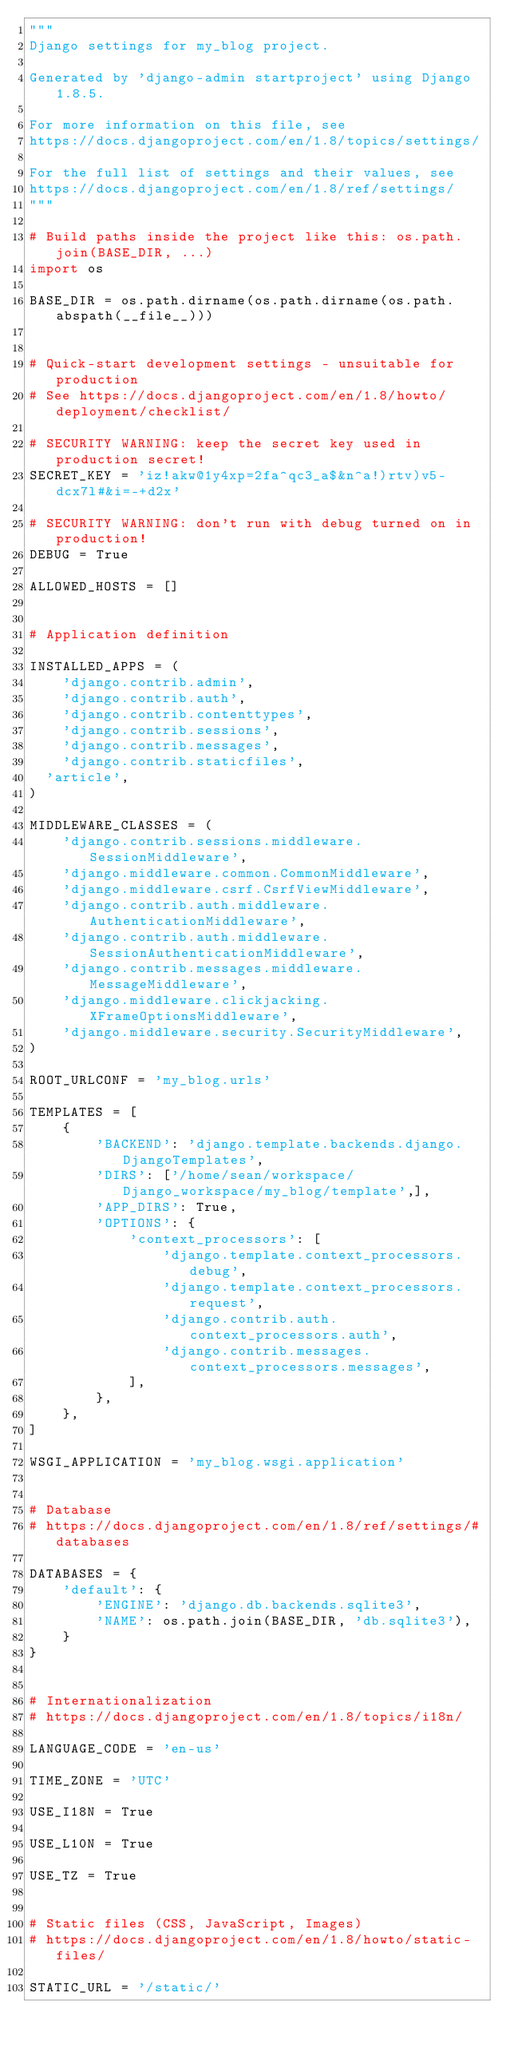Convert code to text. <code><loc_0><loc_0><loc_500><loc_500><_Python_>"""
Django settings for my_blog project.

Generated by 'django-admin startproject' using Django 1.8.5.

For more information on this file, see
https://docs.djangoproject.com/en/1.8/topics/settings/

For the full list of settings and their values, see
https://docs.djangoproject.com/en/1.8/ref/settings/
"""

# Build paths inside the project like this: os.path.join(BASE_DIR, ...)
import os

BASE_DIR = os.path.dirname(os.path.dirname(os.path.abspath(__file__)))


# Quick-start development settings - unsuitable for production
# See https://docs.djangoproject.com/en/1.8/howto/deployment/checklist/

# SECURITY WARNING: keep the secret key used in production secret!
SECRET_KEY = 'iz!akw@1y4xp=2fa^qc3_a$&n^a!)rtv)v5-dcx7l#&i=-+d2x'

# SECURITY WARNING: don't run with debug turned on in production!
DEBUG = True

ALLOWED_HOSTS = []


# Application definition

INSTALLED_APPS = (
    'django.contrib.admin',
    'django.contrib.auth',
    'django.contrib.contenttypes',
    'django.contrib.sessions',
    'django.contrib.messages',
    'django.contrib.staticfiles',
	'article',
)

MIDDLEWARE_CLASSES = (
    'django.contrib.sessions.middleware.SessionMiddleware',
    'django.middleware.common.CommonMiddleware',
    'django.middleware.csrf.CsrfViewMiddleware',
    'django.contrib.auth.middleware.AuthenticationMiddleware',
    'django.contrib.auth.middleware.SessionAuthenticationMiddleware',
    'django.contrib.messages.middleware.MessageMiddleware',
    'django.middleware.clickjacking.XFrameOptionsMiddleware',
    'django.middleware.security.SecurityMiddleware',
)

ROOT_URLCONF = 'my_blog.urls'

TEMPLATES = [
    {
        'BACKEND': 'django.template.backends.django.DjangoTemplates',
        'DIRS': ['/home/sean/workspace/Django_workspace/my_blog/template',],
        'APP_DIRS': True,
        'OPTIONS': {
            'context_processors': [
                'django.template.context_processors.debug',
                'django.template.context_processors.request',
                'django.contrib.auth.context_processors.auth',
                'django.contrib.messages.context_processors.messages',
            ],
        },
    },
]

WSGI_APPLICATION = 'my_blog.wsgi.application'


# Database
# https://docs.djangoproject.com/en/1.8/ref/settings/#databases

DATABASES = {
    'default': {
        'ENGINE': 'django.db.backends.sqlite3',
        'NAME': os.path.join(BASE_DIR, 'db.sqlite3'),
    }
}


# Internationalization
# https://docs.djangoproject.com/en/1.8/topics/i18n/

LANGUAGE_CODE = 'en-us'

TIME_ZONE = 'UTC'

USE_I18N = True

USE_L10N = True

USE_TZ = True


# Static files (CSS, JavaScript, Images)
# https://docs.djangoproject.com/en/1.8/howto/static-files/

STATIC_URL = '/static/'
</code> 